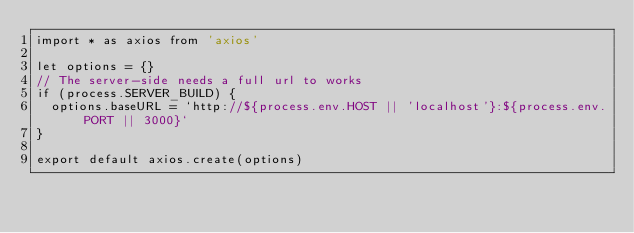<code> <loc_0><loc_0><loc_500><loc_500><_JavaScript_>import * as axios from 'axios'

let options = {}
// The server-side needs a full url to works
if (process.SERVER_BUILD) {
  options.baseURL = `http://${process.env.HOST || 'localhost'}:${process.env.PORT || 3000}`
}

export default axios.create(options)
</code> 